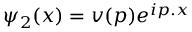<formula> <loc_0><loc_0><loc_500><loc_500>\psi _ { 2 } ( x ) = v ( p ) e ^ { i p . x }</formula> 